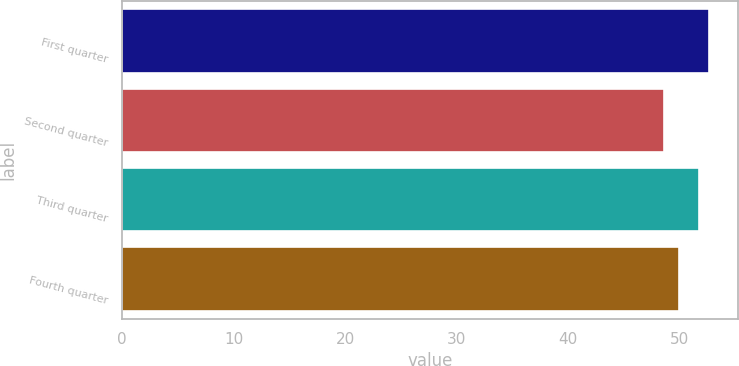<chart> <loc_0><loc_0><loc_500><loc_500><bar_chart><fcel>First quarter<fcel>Second quarter<fcel>Third quarter<fcel>Fourth quarter<nl><fcel>52.6<fcel>48.56<fcel>51.76<fcel>49.93<nl></chart> 